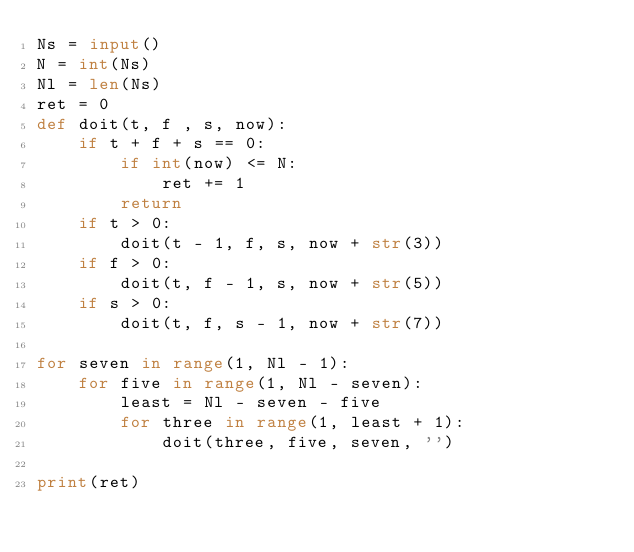Convert code to text. <code><loc_0><loc_0><loc_500><loc_500><_Python_>Ns = input()
N = int(Ns)
Nl = len(Ns)
ret = 0
def doit(t, f , s, now):
    if t + f + s == 0:
        if int(now) <= N:
            ret += 1
        return
    if t > 0:
        doit(t - 1, f, s, now + str(3)) 
    if f > 0:
        doit(t, f - 1, s, now + str(5)) 
    if s > 0:
        doit(t, f, s - 1, now + str(7)) 
    
for seven in range(1, Nl - 1):
    for five in range(1, Nl - seven):
        least = Nl - seven - five
        for three in range(1, least + 1):
            doit(three, five, seven, '')

print(ret)
</code> 